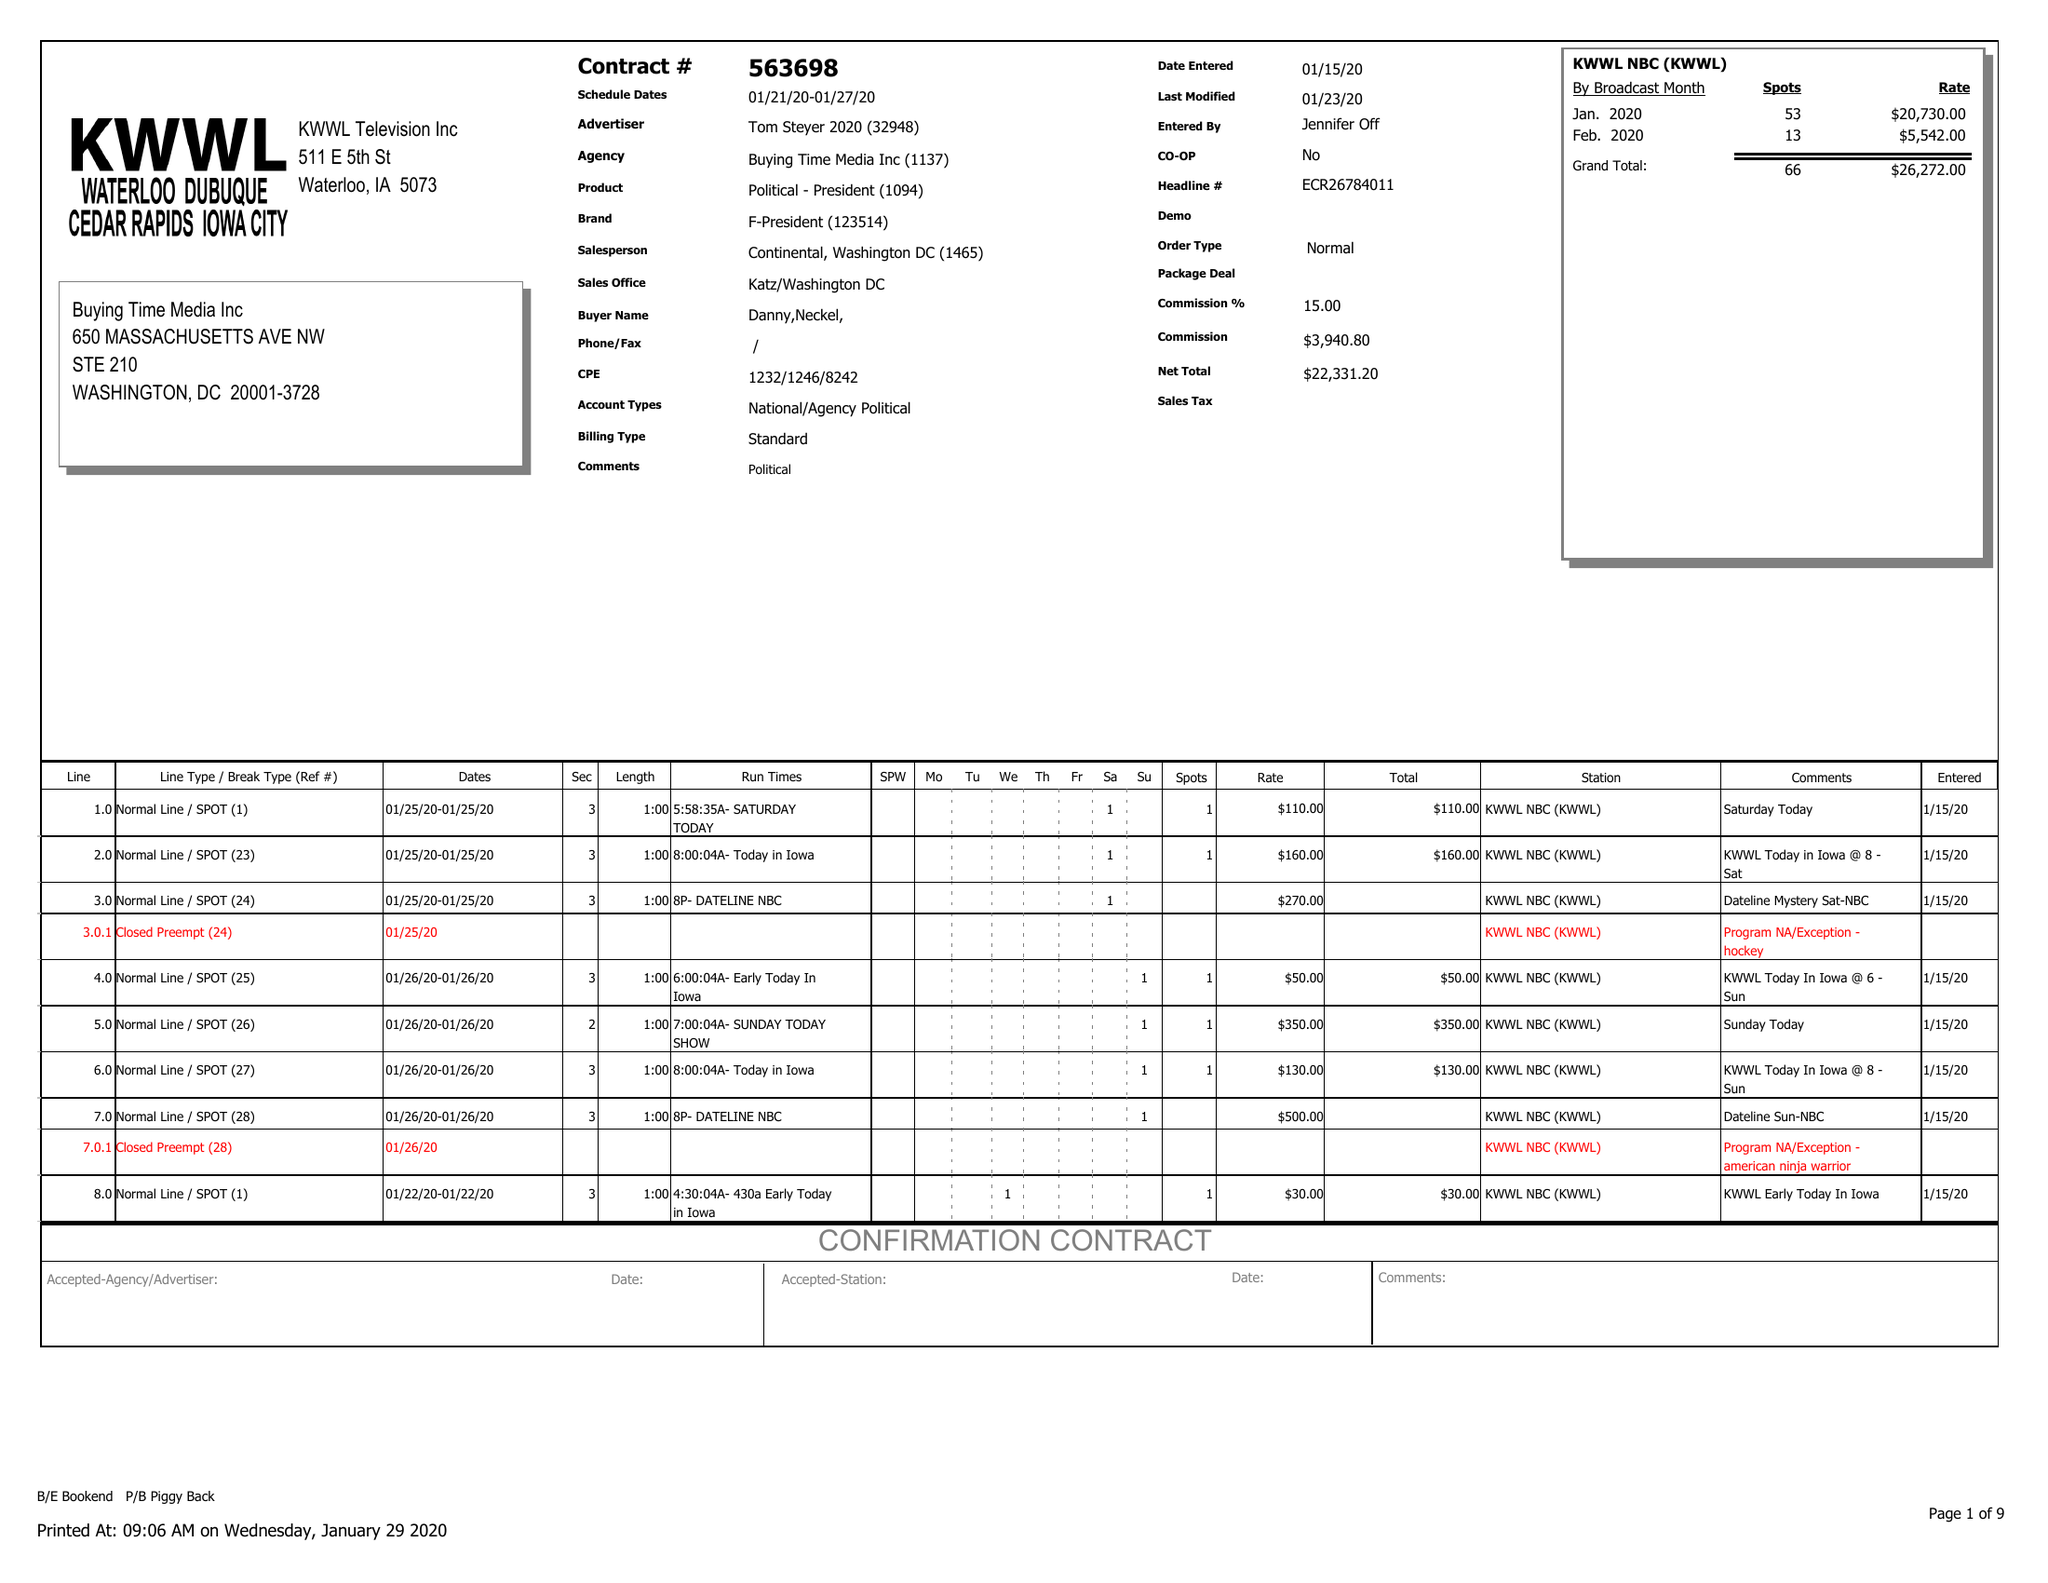What is the value for the advertiser?
Answer the question using a single word or phrase. TOM STEYER 2020 